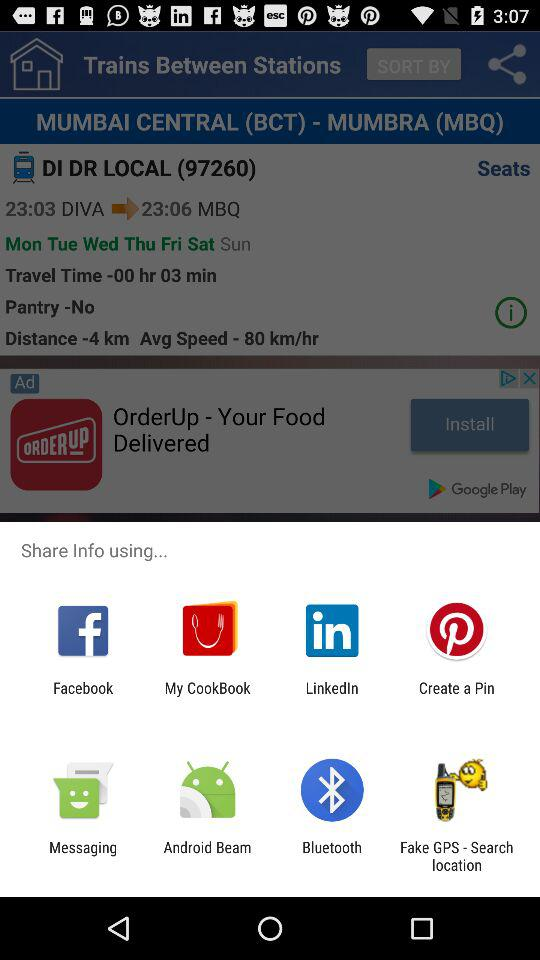What is the given average speed of the train? The given average speed of the train is 80 km/hr. 